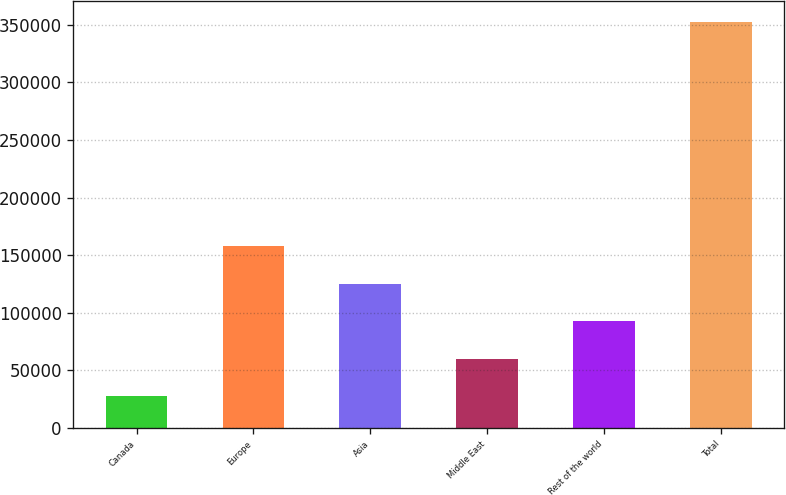Convert chart. <chart><loc_0><loc_0><loc_500><loc_500><bar_chart><fcel>Canada<fcel>Europe<fcel>Asia<fcel>Middle East<fcel>Rest of the world<fcel>Total<nl><fcel>27360<fcel>157482<fcel>124952<fcel>59890.5<fcel>92421<fcel>352665<nl></chart> 